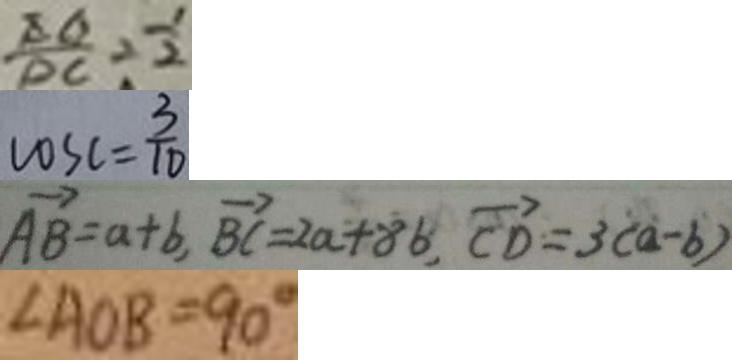Convert formula to latex. <formula><loc_0><loc_0><loc_500><loc_500>\frac { E G } { D C } = \frac { 1 } { 2 } 
 \cos c = \frac { 3 } { 1 0 } 
 \overrightarrow { A B } = a + b , \overrightarrow { B C } = 2 a + 8 b , \overrightarrow { C D } = 3 ( a - b ) 
 \angle A O B = 9 0 ^ { \circ }</formula> 